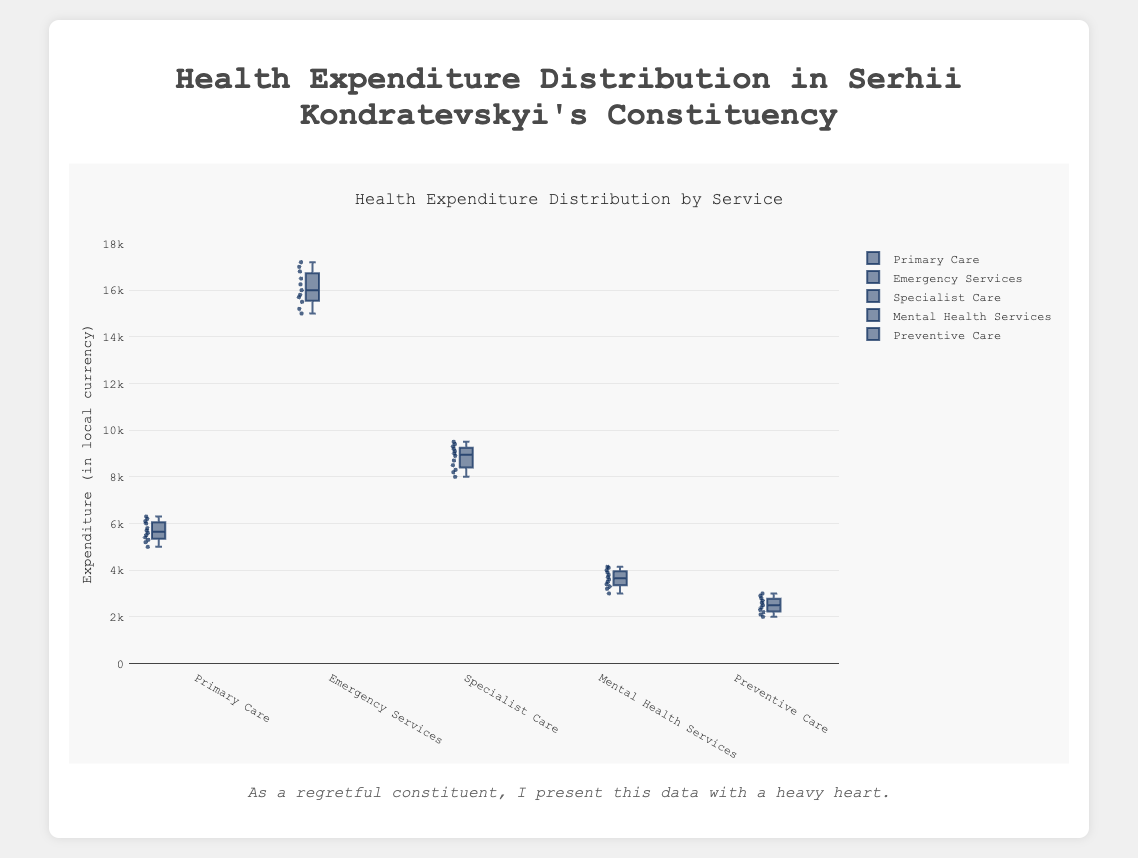What's the title of the figure? The title is at the top of the figure and should describe what the figure is about.
Answer: Health Expenditure Distribution by Service What are the healthcare services included in the figure? The healthcare services are usually listed either on the x-axis or labeled with the data points in the figure.
Answer: Primary Care, Emergency Services, Specialist Care, Mental Health Services, Preventive Care Which healthcare service has the highest maximum expenditure? The maximum expenditure for each service can be identified by the upper whisker or the highest point of the boxplot.
Answer: Emergency Services What is the median expenditure for Specialist Care? The median expenditure is represented by the line inside the box. For Specialist Care, locate the line within its box.
Answer: 9000 Which healthcare service has the smallest interquartile range (IQR)? The IQR is the distance between the first quartile (bottom of the box) and the third quartile (top of the box). Compare the lengths of these boxes across services.
Answer: Emergency Services What is the range of expenditures for Primary Care? The range is the difference between the maximum and minimum values (from the top whisker to the bottom whisker).
Answer: 5000 to 6300 On which healthcare service is the expenditure most variable? The most variable expenditure will have the longest distance between the minimum and maximum points, including outliers.
Answer: Emergency Services What is the first quartile expenditure value for Preventive Care? The first quartile is located at the bottom edge of the box for each service. For Preventive Care, locate this on the Preventive Care box.
Answer: 2200 Compare the median expenditures of Mental Health Services and Specialist Care. Which one is higher? The median is the line inside the box. Find the medians of both services and compare them.
Answer: Specialist Care 